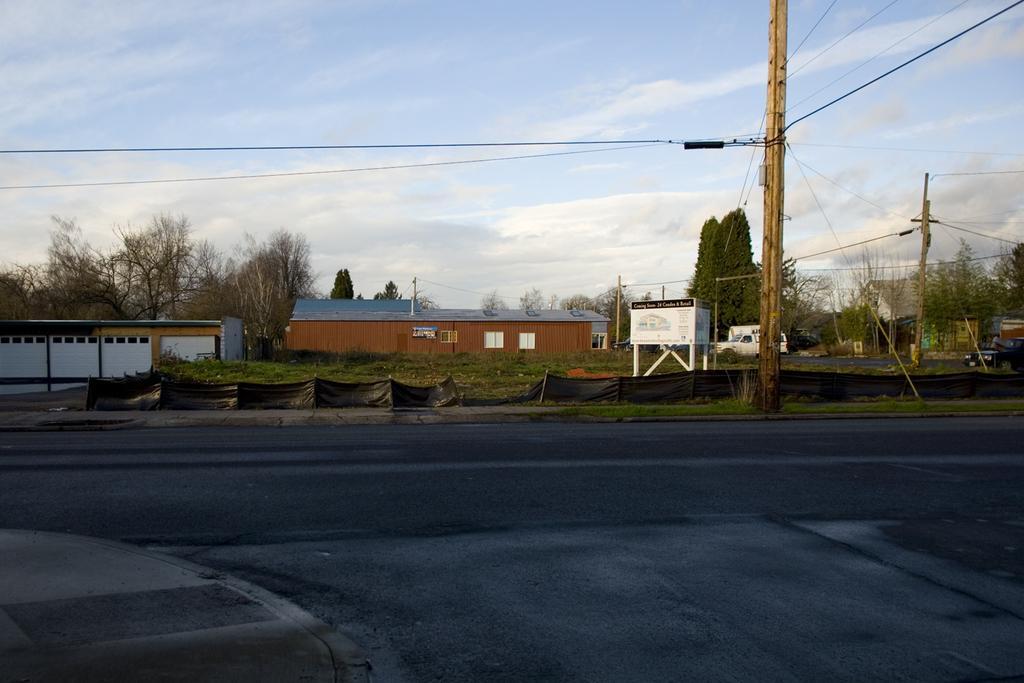Please provide a concise description of this image. In this picture we can see the road with electric poles and wires on the side. In the background, we can see many houses, trees and sign boards. The sky is blue. 